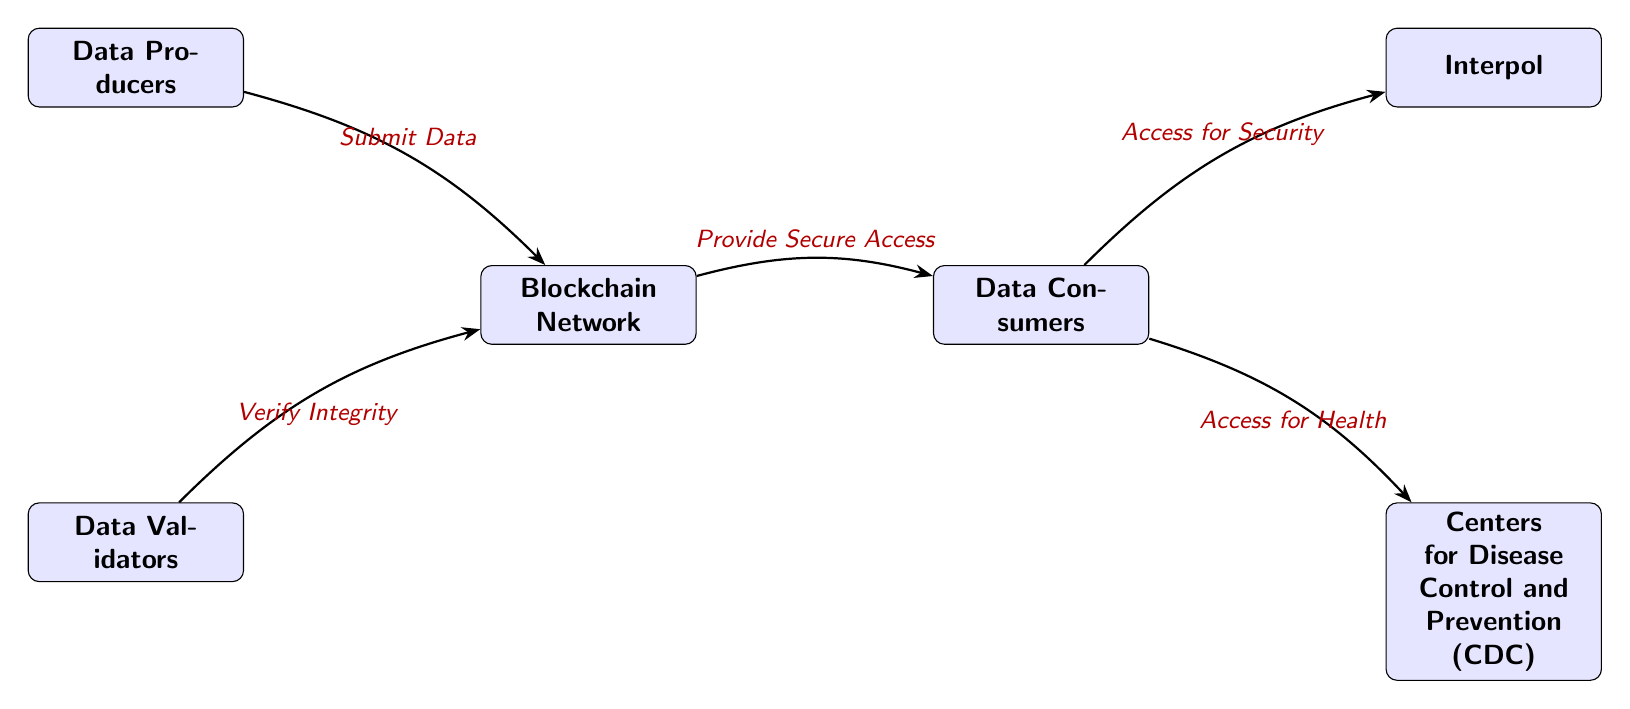What are the two main roles of the blockchain network? The blockchain network serves to provide secure access to data consumers while maintaining integrity through data validation. These roles can be identified from the nodes connected to the blockchain in the diagram.
Answer: Secure access, verify integrity How many entities are there in the diagram? The diagram features six distinct entities, which are 'Blockchain Network', 'Data Producers', 'Data Validators', 'Data Consumers', 'Interpol', and 'Centers for Disease Control and Prevention (CDC)'. Counting them results in a total of six.
Answer: 6 What do data producers do in the blockchain network? According to the diagram, data producers submit data to the blockchain network, which is explicitly indicated by the edge connecting these nodes with the label stating "Submit Data".
Answer: Submit Data Which entity accesses data for health purposes? The diagram shows that the CDC accesses data for health purposes, indicated by the edge connecting the consumers to the CDC with the label "Access for Health".
Answer: Centers for Disease Control and Prevention (CDC) How does the data validation process occur in the diagram? The diagram indicates that data validators are responsible for verifying the integrity of the data submitted to the blockchain network, as shown in the edge labeled "Verify Integrity" connecting the validators to the blockchain.
Answer: Verify Integrity What is the connection between data consumers and Interpol? The diagram depicts a connection between data consumers and Interpol, where consumers access the data explicitly noted as "Access for Security". This indicates that consumers provide some data or information to Interpol.
Answer: Access for Security Which node verifies the integrity of the data? The diagram specifically identifies the data validators as the ones who verify the integrity of the data. This is shown by the directed edge labeled "Verify Integrity" leading from validators to the blockchain node.
Answer: Data Validators Who are the end-users of the data provided by the blockchain network? The end-users of the data in this diagram are the data consumers, and they are linked directly to the blockchain network for secure access.
Answer: Data Consumers 